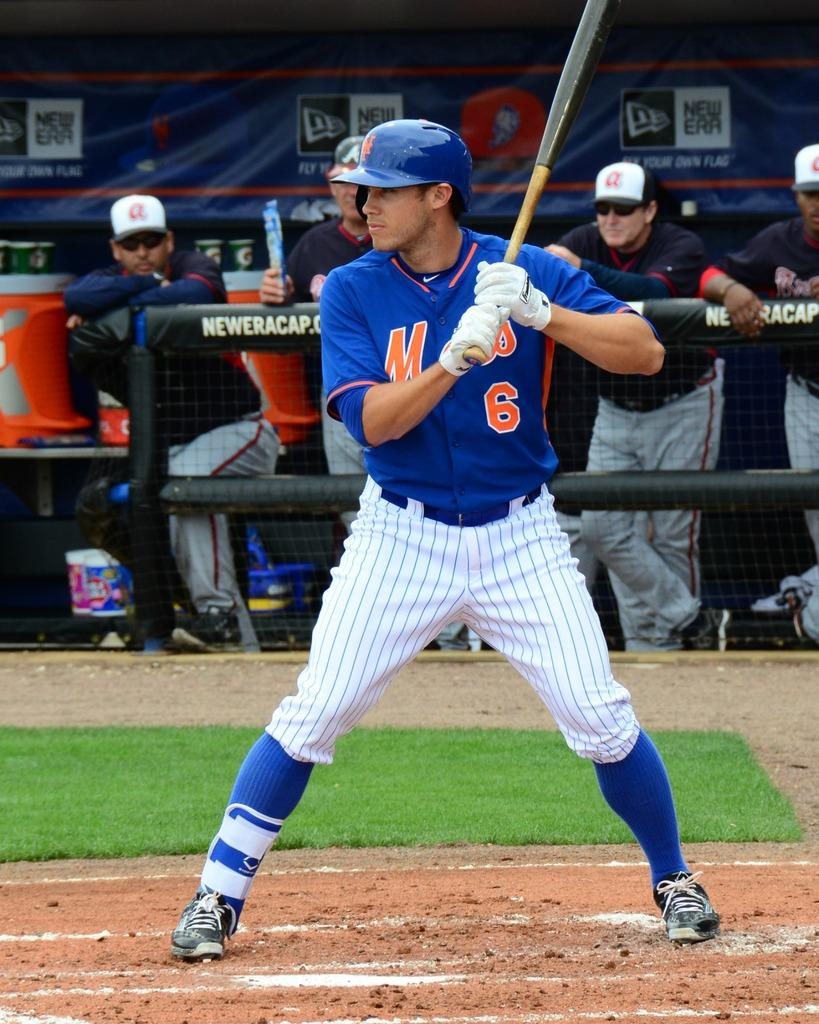<image>
Offer a succinct explanation of the picture presented. A baseball player for the Mets is about to hit a baseball. 